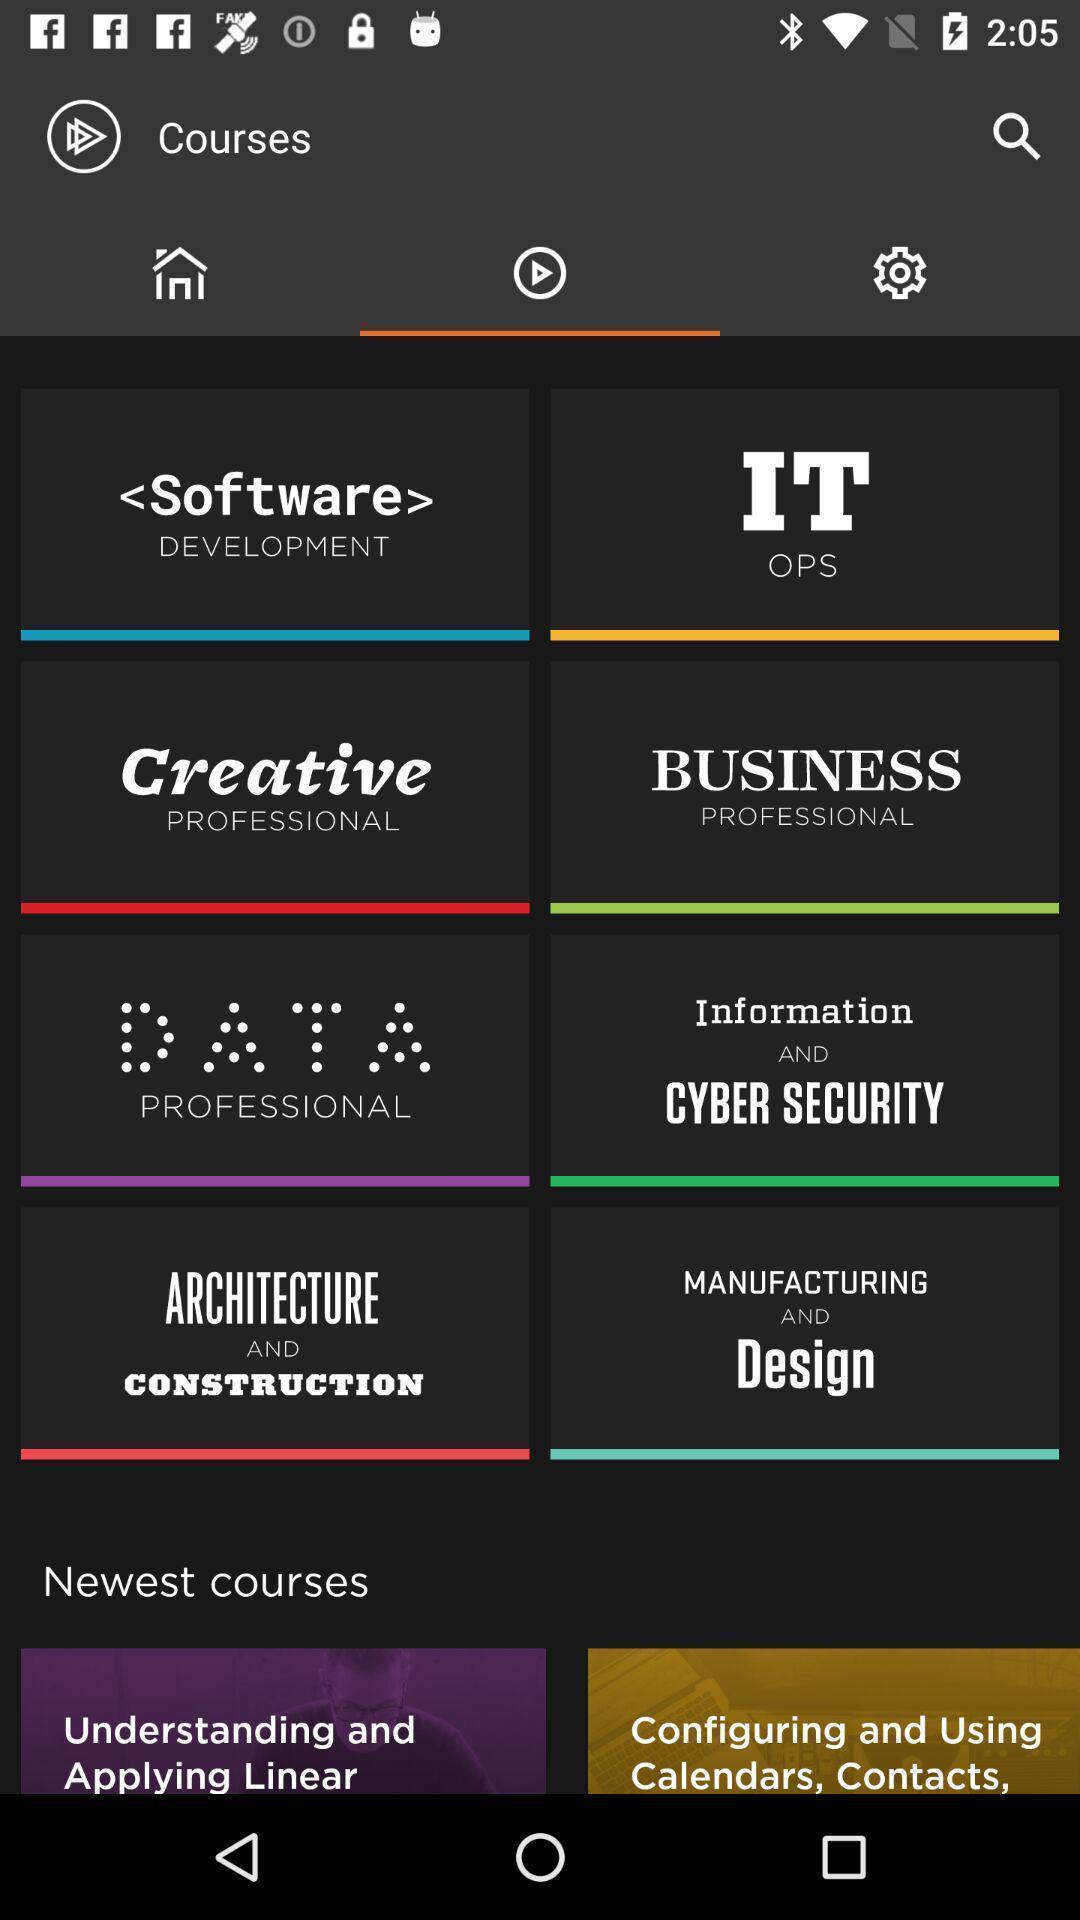Describe the visual elements of this screenshot. Page displaying video courses of a learning app. 